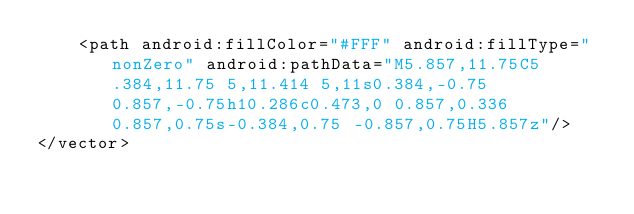Convert code to text. <code><loc_0><loc_0><loc_500><loc_500><_XML_>    <path android:fillColor="#FFF" android:fillType="nonZero" android:pathData="M5.857,11.75C5.384,11.75 5,11.414 5,11s0.384,-0.75 0.857,-0.75h10.286c0.473,0 0.857,0.336 0.857,0.75s-0.384,0.75 -0.857,0.75H5.857z"/>
</vector>
</code> 